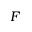<formula> <loc_0><loc_0><loc_500><loc_500>F</formula> 